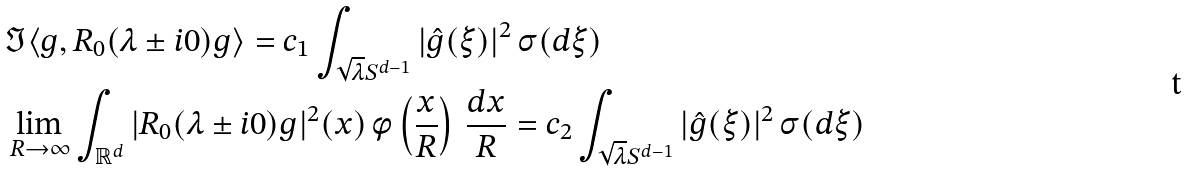Convert formula to latex. <formula><loc_0><loc_0><loc_500><loc_500>& \Im \langle g , R _ { 0 } ( \lambda \pm i 0 ) g \rangle = c _ { 1 } \int _ { \sqrt { \lambda } S ^ { d - 1 } } | \hat { g } ( \xi ) | ^ { 2 } \, \sigma ( d \xi ) \\ & \lim _ { R \to \infty } \int _ { \mathbb { R } ^ { d } } | R _ { 0 } ( \lambda \pm i 0 ) g | ^ { 2 } ( x ) \, \phi \left ( \frac { x } { R } \right ) \, \frac { d x } { R } = c _ { 2 } \int _ { \sqrt { \lambda } S ^ { d - 1 } } | \hat { g } ( \xi ) | ^ { 2 } \, \sigma ( d \xi )</formula> 